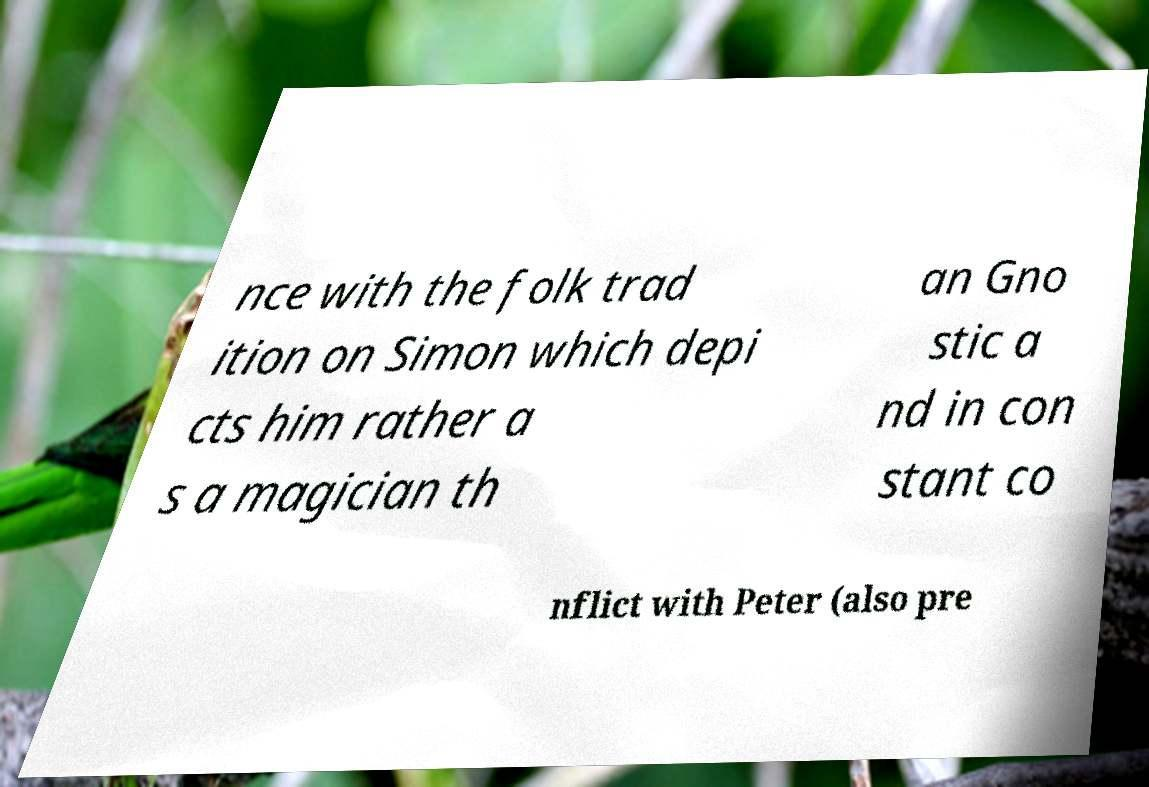Please read and relay the text visible in this image. What does it say? nce with the folk trad ition on Simon which depi cts him rather a s a magician th an Gno stic a nd in con stant co nflict with Peter (also pre 